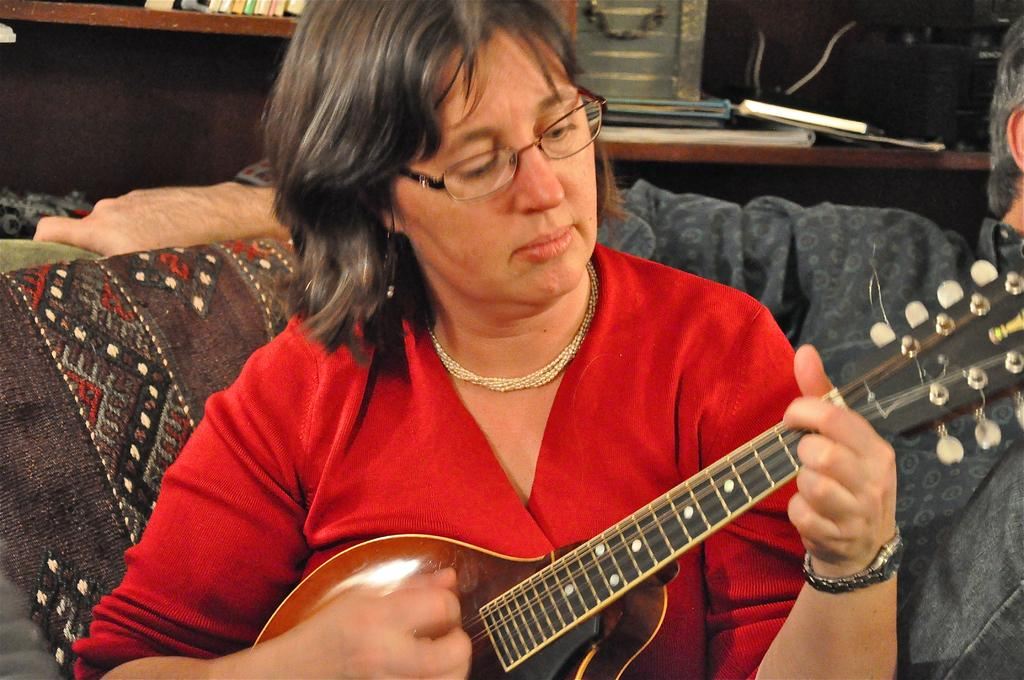What is the woman in the image doing? The woman is playing a guitar in the image. Where is the woman sitting? The woman is sitting on a couch in the image. Who is beside the woman on the couch? There is a man beside the woman on the couch in the image. What is the woman wearing? The woman is wearing a red color dress, glasses, and a necklace in the image. Are the children playing with a rifle in the image? There are no children or rifles present in the image. 